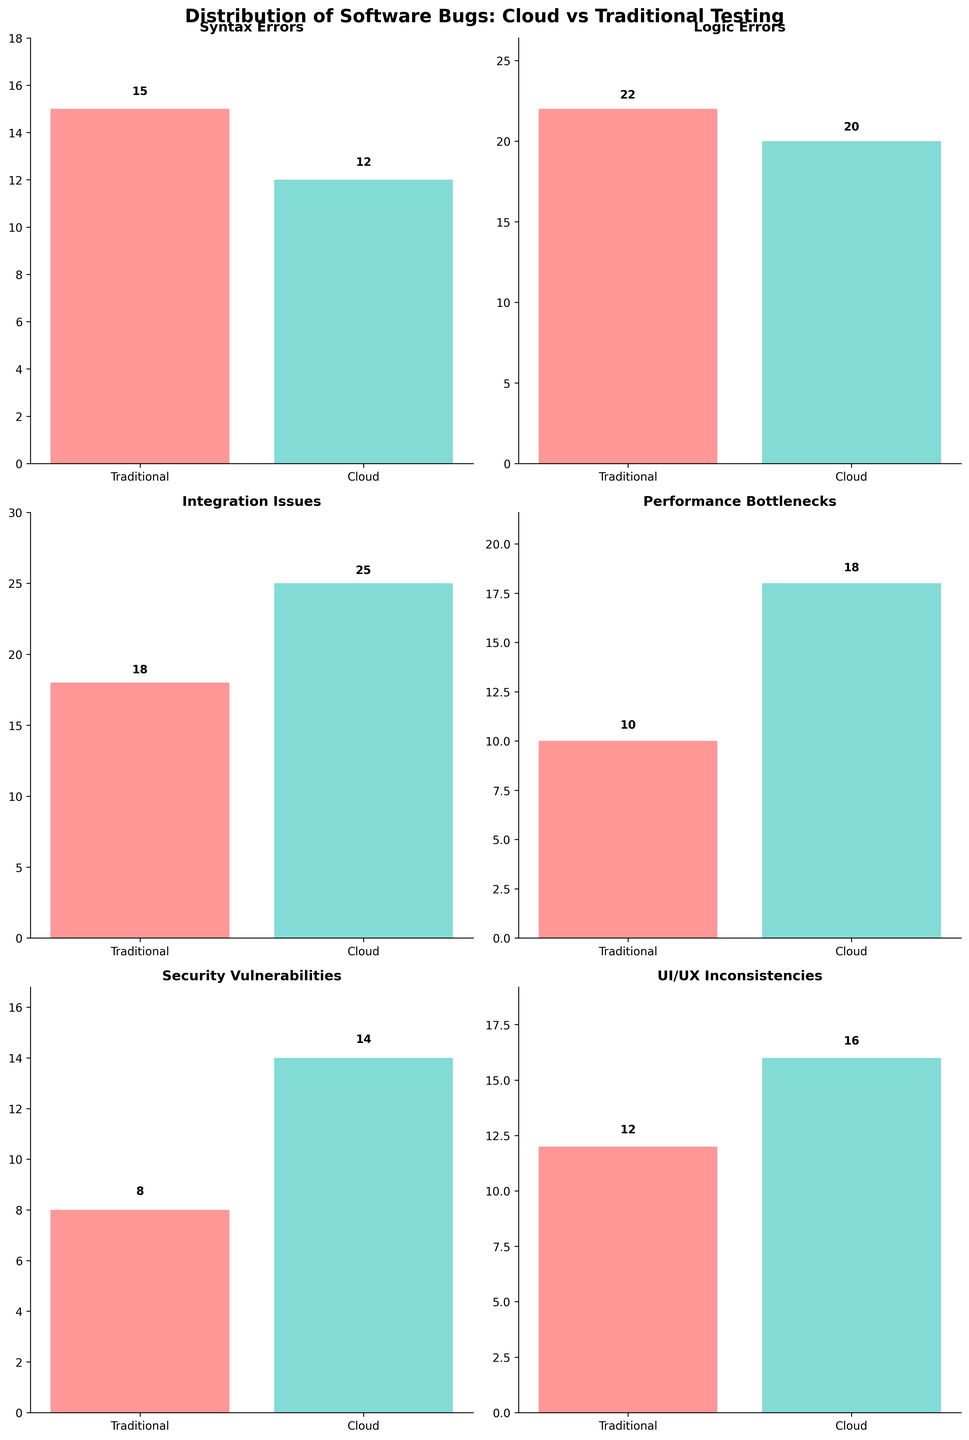What is the title of the figure? The title is located at the top of the figure. By looking at the title text, we can see it is "Distribution of Software Bugs: Cloud vs Traditional Testing".
Answer: Distribution of Software Bugs: Cloud vs Traditional Testing Which testing method catches more security vulnerabilities? By examining the bars associated with "Security Vulnerabilities" for both testing methods, we see that the bar for Cloud Testing is higher (14) compared to Traditional Testing (8).
Answer: Cloud Testing What is the difference in the number of performance bottlenecks detected by cloud testing vs traditional testing? The "Performance Bottlenecks" subplot shows that Cloud Testing catches 18 bottlenecks while Traditional Testing catches 10. Subtract the two numbers: 18 - 10 = 8.
Answer: 8 How many types of software bugs are displayed in the figure? The figure has subplots where each subplot corresponds to a type of software bug. Counting the titles of the subplots reveals six types: Syntax Errors, Logic Errors, Integration Issues, Performance Bottlenecks, Security Vulnerabilities, and UI/UX Inconsistencies.
Answer: 6 Which type of software bug shows the largest difference in detection between cloud testing and traditional testing? Observe the differences in detection for each type of bug by subtracting the values. The largest occurs in Integration Issues where Cloud Testing detects 25 and Traditional Testing detects 18. The difference is 7.
Answer: Integration Issues What is the combined total of logic errors detected by both testing methods? The "Logic Errors" subplot shows that Cloud Testing detects 20 logic errors and Traditional Testing detects 22. Summing these values: 20 + 22 = 42.
Answer: 42 Which testing method shows a higher average number of bugs detected across all types? Calculate the average for each method. For Traditional Testing: (15 + 22 + 18 + 10 + 8 + 12)/6 = 14.17. For Cloud Testing: (12 + 20 + 25 + 18 + 14 + 16)/6 = 17.50. Cloud Testing has a higher average.
Answer: Cloud Testing Are there any software bug categories where traditional testing detects more bugs than cloud testing? Compare the values of both methods for each bug type. Traditional Testing detects more bugs in "Syntax Errors" (15 vs 12) and "Logic Errors" (22 vs 20).
Answer: Yes Which category has the smallest number of bugs detected by cloud testing? Examine the Cloud Testing bars for all bug categories. The smallest number is found in "Syntax Errors" with 12 bugs detected.
Answer: Syntax Errors What is the percentage increase in the number of UI/UX inconsistencies detected by cloud testing compared to traditional testing? Traditional Testing detects 12 UI/UX inconsistencies, while Cloud Testing detects 16. The percentage increase is calculated by ((16 - 12) / 12) * 100 = 33.33%.
Answer: 33.33% 